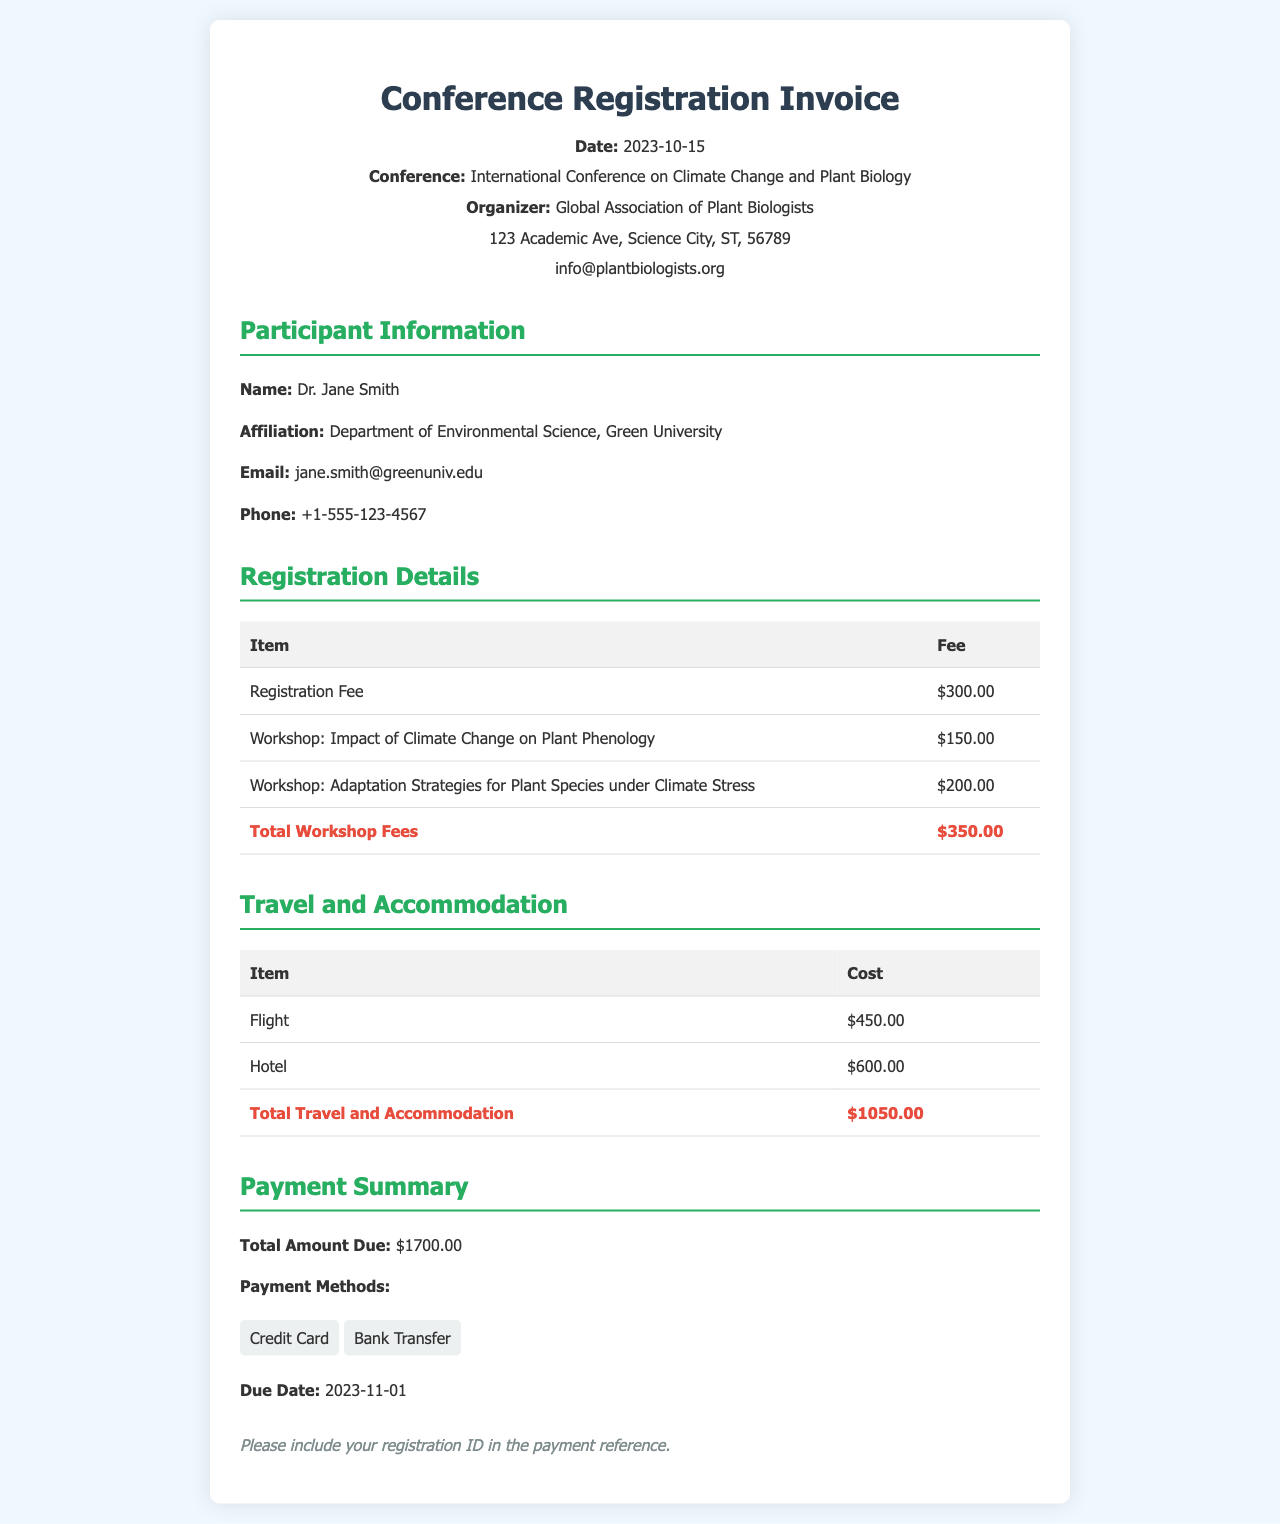What is the total amount due? The total amount due is stated at the end of the payment summary section of the invoice, which includes all registration and accommodation fees.
Answer: $1700.00 What is the date of the conference? The date of the conference is mentioned in the header section of the invoice under the date label.
Answer: 2023-10-15 Who is the participant? The participant’s name is specified in the participant information section of the invoice.
Answer: Dr. Jane Smith How much is the registration fee? The registration fee is listed in the registration details section of the invoice under the item "Registration Fee".
Answer: $300.00 What is included in total travel and accommodation costs? Total travel and accommodation costs is the sum of flight and hotel costs, mentioned in their respective sections.
Answer: $1050.00 What workshop focuses on plant phenology? The specific workshop focusing on plant phenology is listed in the registration details section.
Answer: Workshop: Impact of Climate Change on Plant Phenology What is the due date for the payment? The due date for the payment is indicated in the payment summary section of the invoice.
Answer: 2023-11-01 What are the payment methods available? The payment methods are listed in the payment summary section, indicating options for payment.
Answer: Credit Card, Bank Transfer 